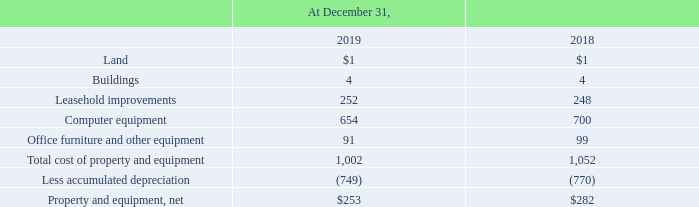6. Property and Equipment, Net
Property and equipment, net was comprised of the following (amounts in millions):
Depreciation expense for the years ended December 31, 2019, 2018, and 2017 was $124 million, $138 million, and $130 million, respectively.
What was the depreciation expense for 2017?
Answer scale should be: million. $130 million. What was the depreciation expense for 2019?
Answer scale should be: million. $124 million. What was the net cost of Land in 2019?
Answer scale should be: million. $1. What was the change in the net cost of computer equipment between 2018 and 2019?
Answer scale should be: million. 654-700
Answer: -46. What was the change in the property and equipment, net between 2018 and 2019?
Answer scale should be: million. 253-282
Answer: -29. What was the percentage change in total cost of property and equipment between 2018 and 2019?
Answer scale should be: percent. (1,002-1,052)/1,052
Answer: -4.75. 